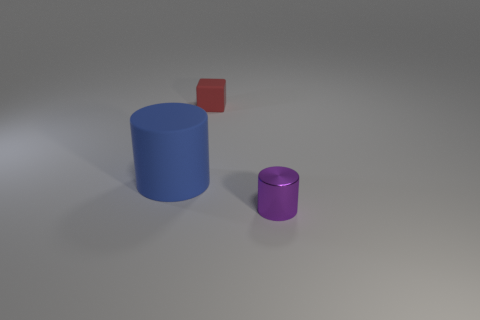Are there any purple metallic cylinders that are behind the object that is in front of the matte object that is in front of the small red matte object?
Offer a very short reply. No. There is a matte cube; how many large blue objects are to the left of it?
Provide a short and direct response. 1. How many cylinders have the same color as the small metallic object?
Your answer should be very brief. 0. How many objects are either rubber things that are behind the big cylinder or things that are in front of the red thing?
Ensure brevity in your answer.  3. Are there more blue matte cylinders than big cyan spheres?
Your response must be concise. Yes. There is a object that is behind the big blue matte cylinder; what is its color?
Offer a terse response. Red. Is the large thing the same shape as the metal thing?
Make the answer very short. Yes. There is a thing that is behind the small purple thing and on the right side of the big cylinder; what is its color?
Ensure brevity in your answer.  Red. Does the cylinder behind the tiny purple metallic object have the same size as the purple shiny cylinder that is to the right of the red matte cube?
Ensure brevity in your answer.  No. How many things are either objects in front of the large matte cylinder or matte objects?
Offer a very short reply. 3. 